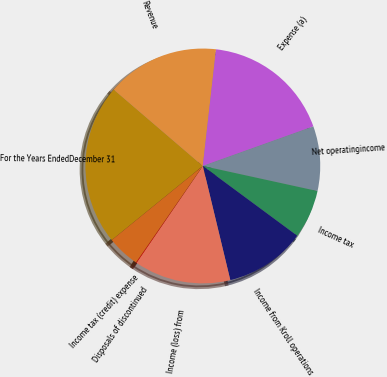Convert chart. <chart><loc_0><loc_0><loc_500><loc_500><pie_chart><fcel>For the Years EndedDecember 31<fcel>Revenue<fcel>Expense (a)<fcel>Net operatingincome<fcel>Income tax<fcel>Income from Kroll operations<fcel>Income (loss) from<fcel>Disposals of discontinued<fcel>Income tax (credit) expense<nl><fcel>22.15%<fcel>15.52%<fcel>17.73%<fcel>8.9%<fcel>6.7%<fcel>11.11%<fcel>13.32%<fcel>0.08%<fcel>4.49%<nl></chart> 